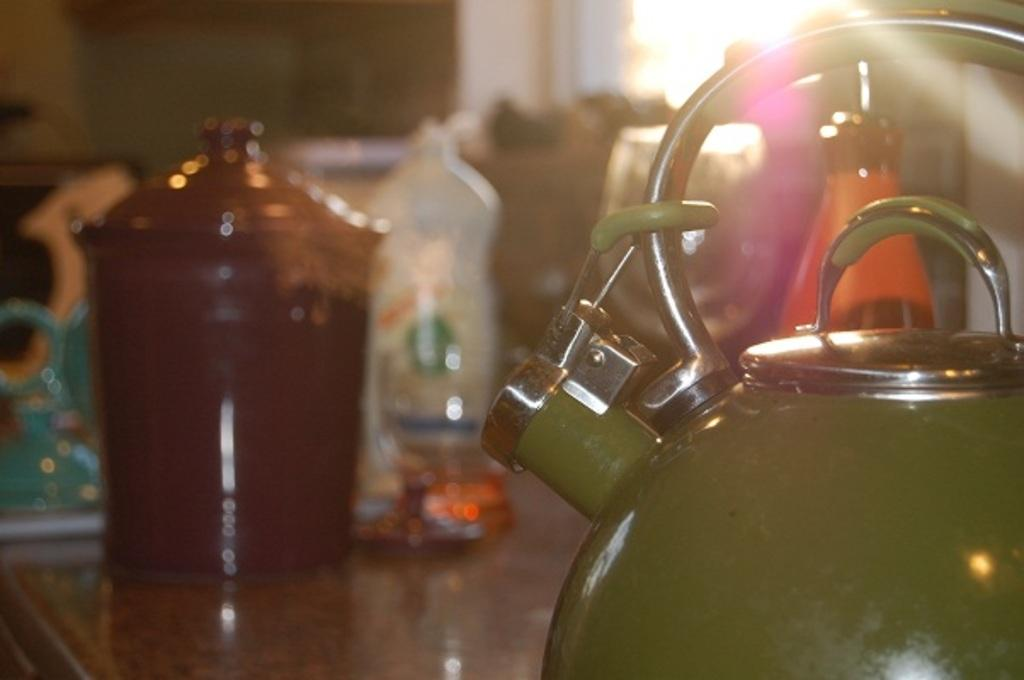What object is the main focus of the image? There is a kettle in the image. What color is the kettle? The kettle is green in color. Where is the kettle placed? The kettle is placed on a table. What else can be seen on the table? There is a group of bottles on the table. What can be seen in the background of the image? There is a window visible in the background of the image. What word is written on the kettle in the image? There is no word written on the kettle in the image; it is just a plain green kettle. What type of alarm is present in the image? There is no alarm present in the image; it only features a kettle, a table, a group of bottles, and a window in the background. 